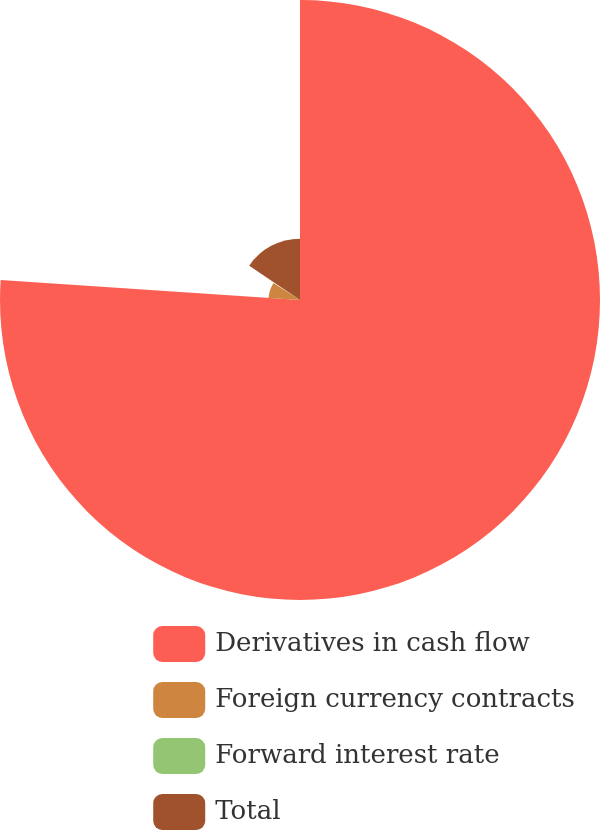<chart> <loc_0><loc_0><loc_500><loc_500><pie_chart><fcel>Derivatives in cash flow<fcel>Foreign currency contracts<fcel>Forward interest rate<fcel>Total<nl><fcel>76.06%<fcel>7.98%<fcel>0.42%<fcel>15.54%<nl></chart> 